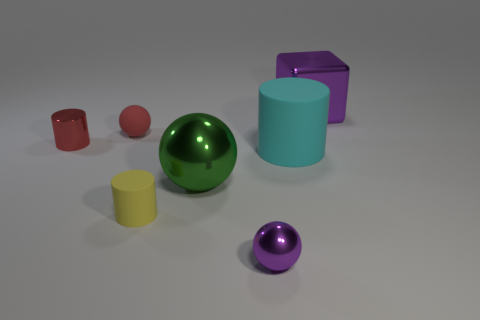Add 2 green shiny spheres. How many objects exist? 9 Subtract all blocks. How many objects are left? 6 Add 2 tiny red matte things. How many tiny red matte things are left? 3 Add 2 small red cylinders. How many small red cylinders exist? 3 Subtract 1 red balls. How many objects are left? 6 Subtract all yellow cylinders. Subtract all big cyan rubber objects. How many objects are left? 5 